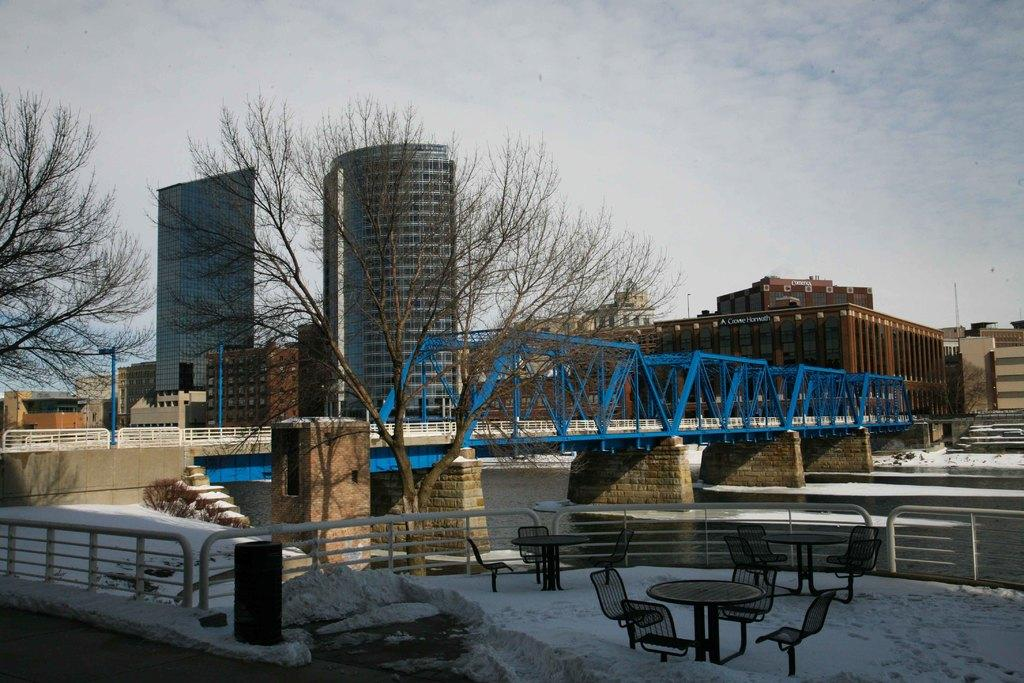What type of structures can be seen in the image? There are buildings in the image. What natural feature is present in the image? There is a bridgewater in the image. What is the weather like in the image? There is snow in the image, indicating a cold climate. What type of furniture is visible in the image? There is a table and chairs in the image. What type of vegetation is present in the image? There are trees in the image. What is visible in the sky in the image? The sky is visible in the image, and clouds are present. What type of unit is being measured by the beggar in the image? There is no beggar present in the image, so this question cannot be answered. What type of apparel is the beggar wearing in the image? There is no beggar present in the image, so this question cannot be answered. 